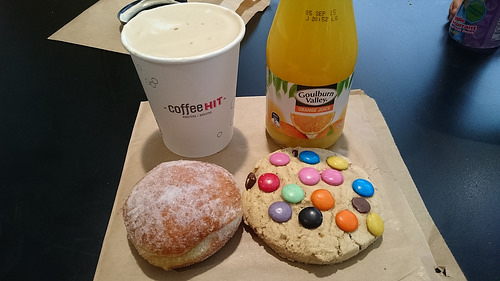<image>
Is the orange juice next to the cookie? Yes. The orange juice is positioned adjacent to the cookie, located nearby in the same general area. 